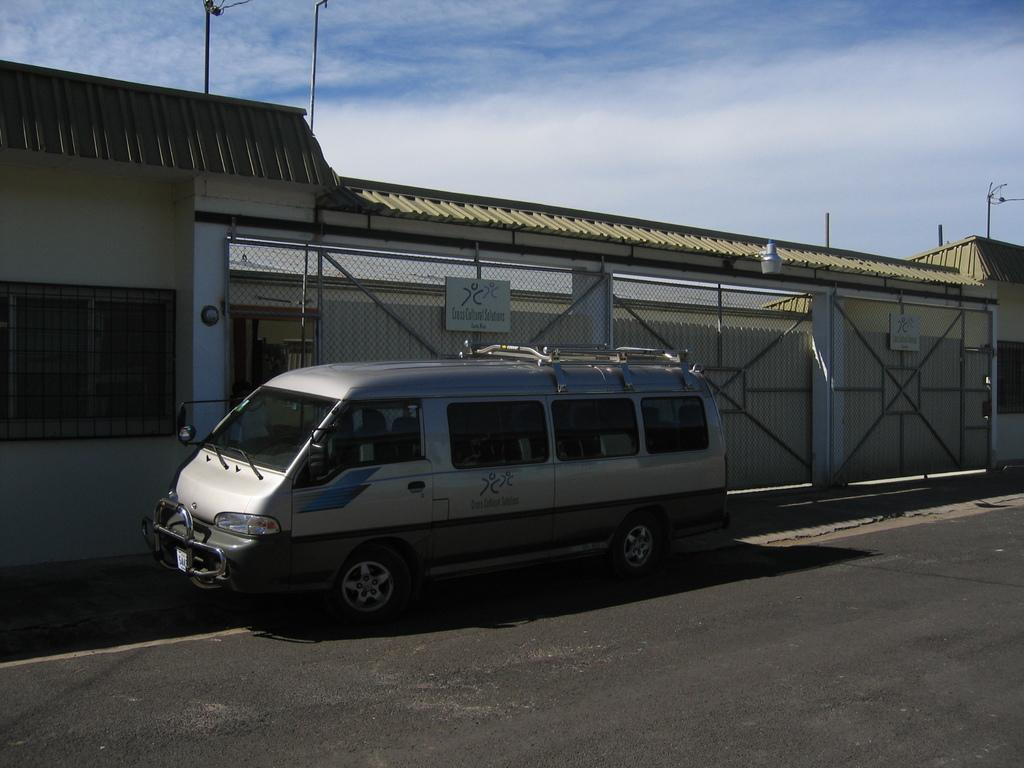What is the main subject of the image? There is a vehicle on the road in the image. What can be seen in the background of the image? Walls, roofs, gates with boards, poles, and clouds in the sky are visible in the background of the image. What type of vessel is being used to limit the loss of water in the image? There is no vessel or water present in the image, so it is not possible to determine if any are being used to limit the loss of water. 